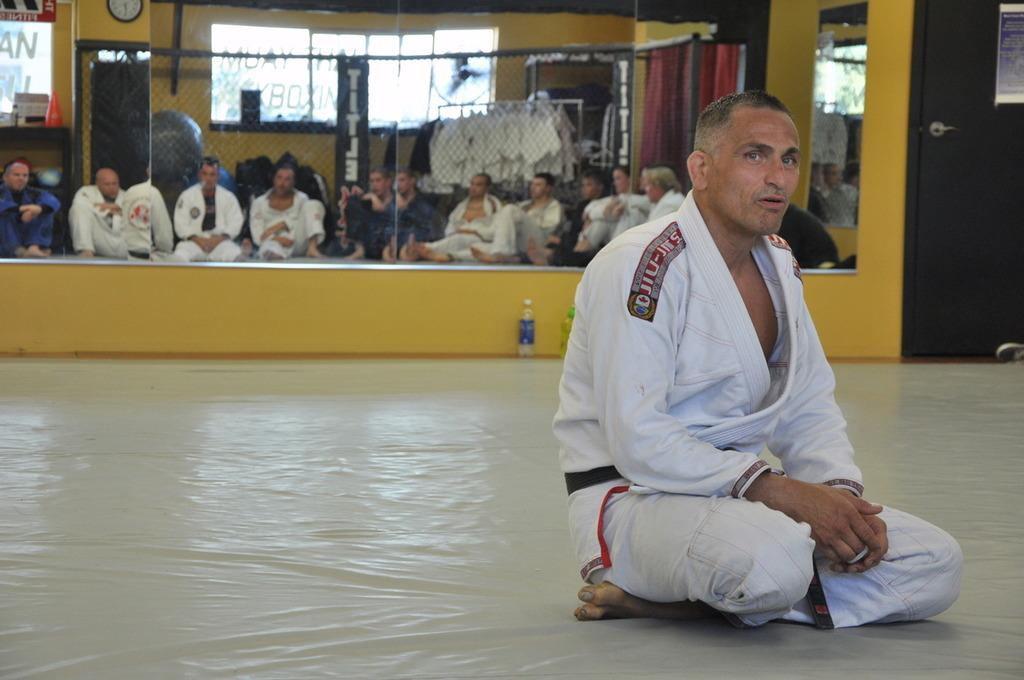<image>
Describe the image concisely. a karate fighter on the ground with jiu written on him 